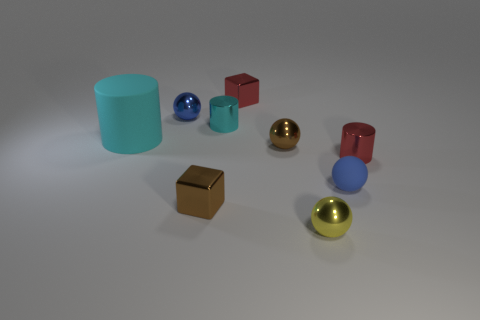Subtract all small metallic balls. How many balls are left? 1 Subtract all red cubes. How many cubes are left? 1 Subtract all brown balls. Subtract all cyan cylinders. How many balls are left? 3 Subtract all green spheres. How many red blocks are left? 1 Subtract all cyan matte objects. Subtract all metal spheres. How many objects are left? 5 Add 5 small red cubes. How many small red cubes are left? 6 Add 4 purple metallic things. How many purple metallic things exist? 4 Subtract 0 yellow cylinders. How many objects are left? 9 Subtract all cylinders. How many objects are left? 6 Subtract 4 balls. How many balls are left? 0 